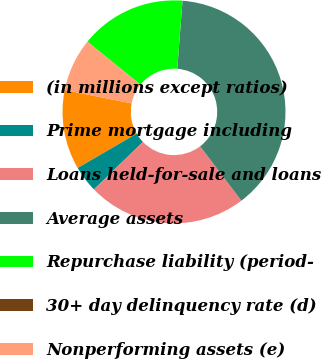Convert chart to OTSL. <chart><loc_0><loc_0><loc_500><loc_500><pie_chart><fcel>(in millions except ratios)<fcel>Prime mortgage including<fcel>Loans held-for-sale and loans<fcel>Average assets<fcel>Repurchase liability (period-<fcel>30+ day delinquency rate (d)<fcel>Nonperforming assets (e)<nl><fcel>11.54%<fcel>3.85%<fcel>23.08%<fcel>38.46%<fcel>15.38%<fcel>0.0%<fcel>7.69%<nl></chart> 